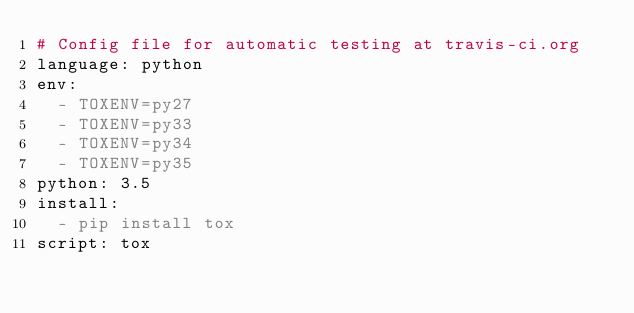Convert code to text. <code><loc_0><loc_0><loc_500><loc_500><_YAML_># Config file for automatic testing at travis-ci.org
language: python
env:
  - TOXENV=py27
  - TOXENV=py33
  - TOXENV=py34
  - TOXENV=py35
python: 3.5
install:
  - pip install tox
script: tox
</code> 